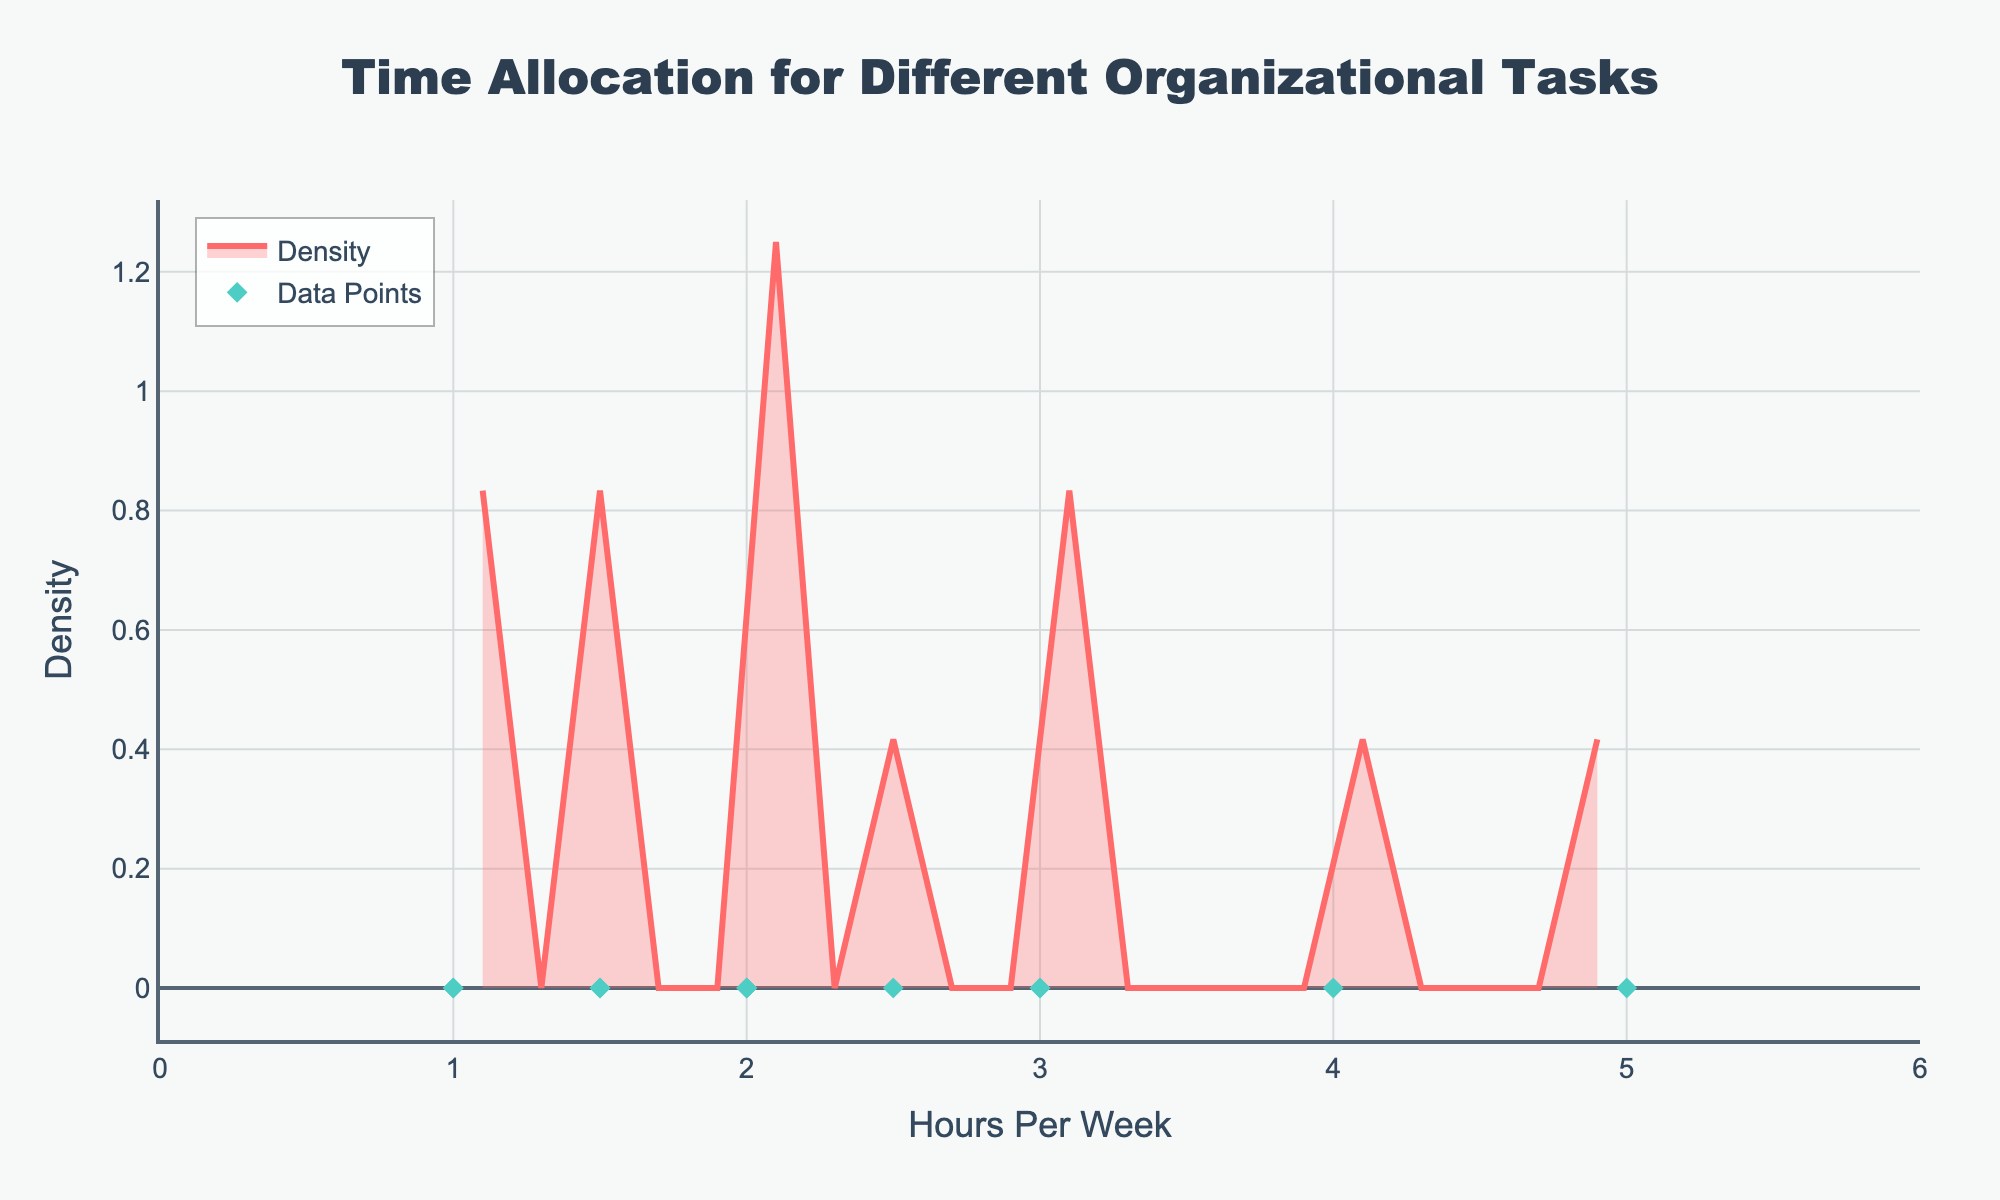What is the title of the plot? The title is usually displayed at the top of the plot. Reading it directly from there, we can see that the title is "Time Allocation for Different Organizational Tasks".
Answer: Time Allocation for Different Organizational Tasks How many tasks show zero density? Zero density indicates there are no tasks with that specific time allocation. By looking closely at the x-axis and the density curve, any sections where the curve touches the baseline show zero density.
Answer: None Which task has the maximum hours per week? Observing the scatter plot of individual data points, the task with the highest x-value represents the maximum hours per week.
Answer: Event Planning Compare Event Planning and Budget Management in terms of hours per week. Event Planning hours are represented by the rightmost data point, while Budget Management is identified by looking at the respective data points. Event Planning has 5 hours per week, and Budget Management has 2 hours per week.
Answer: Event Planning has more hours per week than Budget Management What is the range of hours per week represented in the plot? The x-axis of the plot shows the range of hours per week. By looking at its span from the smallest to the largest value, we can determine the range. The smallest value is 1 and the largest value is 5.
Answer: 1 to 5 How is density visually represented in the plot? Density is typically shown as a smooth curve that fills the area under it. The plot uses a filled curve under a smoothed line to indicate density variations.
Answer: A filled curve under a smoothed line Which color is used for the data points? The data points are identified by their unique visual representation, often with distinct colors and shapes. Here, they appear as diamond-shaped points in the plot.
Answer: Teal Calculate the mean hours per week for all tasks. To find the mean, add all hours and divide by the number of tasks. Summing up the hours (5 + 3 + 4 + 2 + 1 + 1.5 + 3 + 2.5 + 1 + 2 + 1.5 + 2) and dividing by 12 yields 29.5/12 ≈ 2.46.
Answer: 2.46 Identify the task with the median hours per week. Arrange tasks in ascending order of hours (1, 1, 1.5, 1.5, 2, 2, 2.5, 3, 3, 4, 5) and find the middle value(s). Here, the median falls between 2 and 2.5.
Answer: Budget Management and Meeting Organization (median is between these) What can we infer about the most common time allocation range? The density plot peaks indicate where data points cluster. Identifying peak regions can show the most common allocation range. The region around 2 hours per week shows a peak density.
Answer: Around 2 hours per week 